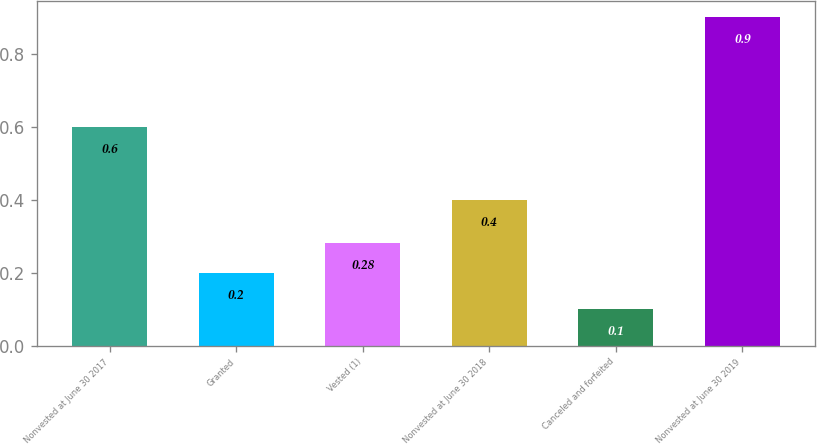Convert chart to OTSL. <chart><loc_0><loc_0><loc_500><loc_500><bar_chart><fcel>Nonvested at June 30 2017<fcel>Granted<fcel>Vested (1)<fcel>Nonvested at June 30 2018<fcel>Canceled and forfeited<fcel>Nonvested at June 30 2019<nl><fcel>0.6<fcel>0.2<fcel>0.28<fcel>0.4<fcel>0.1<fcel>0.9<nl></chart> 